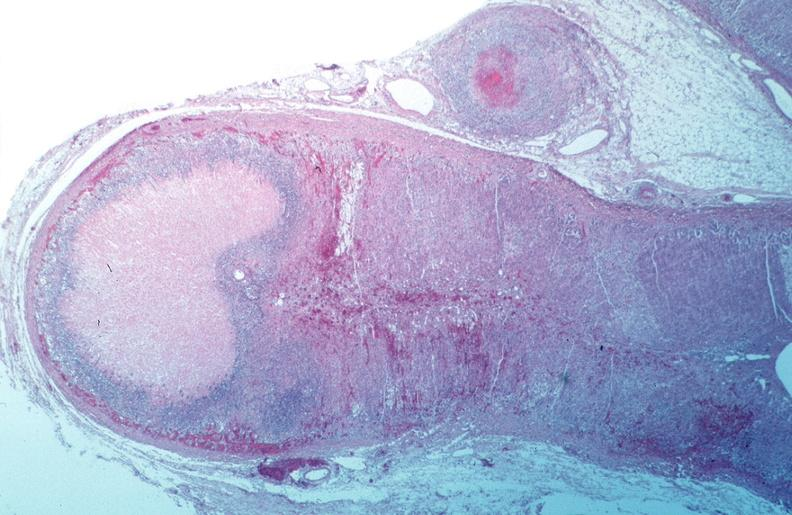s vasculature present?
Answer the question using a single word or phrase. Yes 